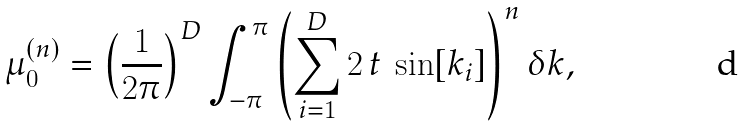<formula> <loc_0><loc_0><loc_500><loc_500>\mu _ { 0 } ^ { ( n ) } = \left ( \frac { 1 } { 2 \pi } \right ) ^ { D } \int _ { - \pi } ^ { \pi } \left ( \sum _ { i = 1 } ^ { D } 2 \, t \, \sin [ k _ { i } ] \right ) ^ { n } \delta k ,</formula> 